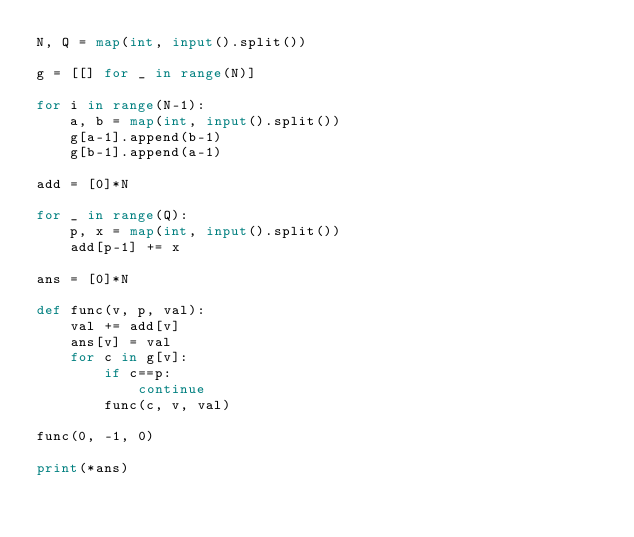<code> <loc_0><loc_0><loc_500><loc_500><_Python_>N, Q = map(int, input().split())

g = [[] for _ in range(N)]

for i in range(N-1):
    a, b = map(int, input().split())
    g[a-1].append(b-1)
    g[b-1].append(a-1)

add = [0]*N

for _ in range(Q):
    p, x = map(int, input().split())
    add[p-1] += x

ans = [0]*N

def func(v, p, val):
    val += add[v]
    ans[v] = val
    for c in g[v]:
        if c==p:
            continue
        func(c, v, val)

func(0, -1, 0)

print(*ans)</code> 